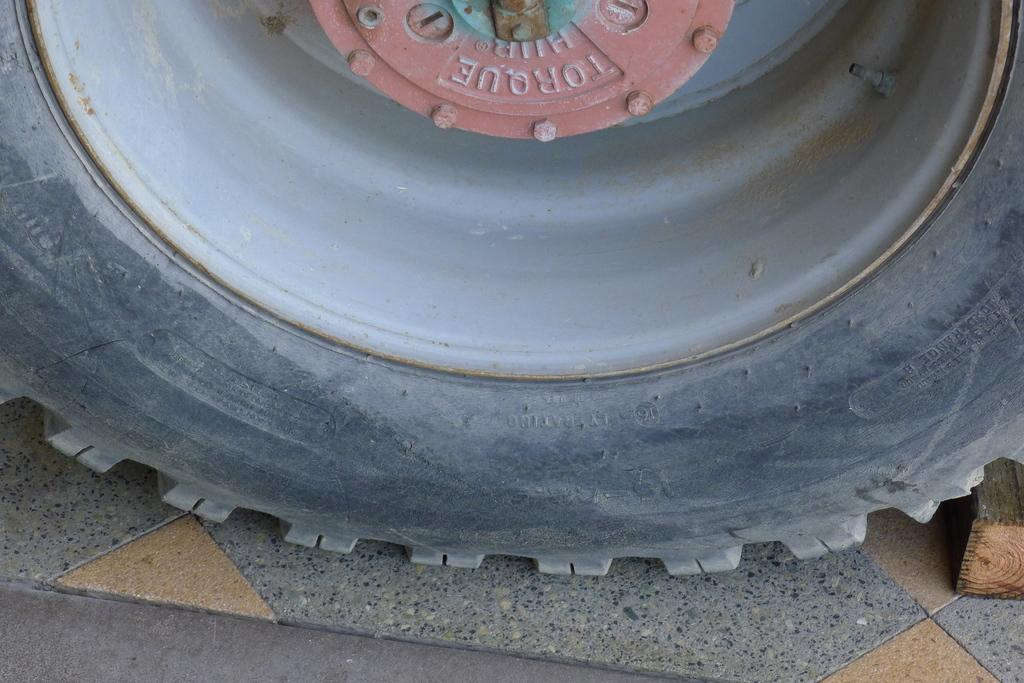What is the main object in the center of the image? There is a tire in the center of the image. What is written or printed on the tire? There is text on the tire. What can be seen on the right side of the image? There is a wood on the right side of the image. Can you see a squirrel holding a badge on the tire in the image? No, there is no squirrel or badge present on the tire in the image. 